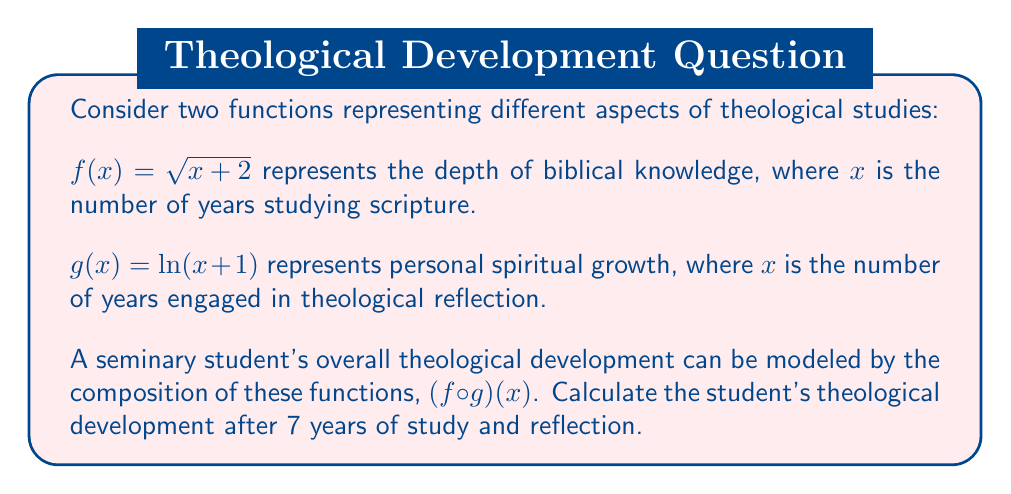Give your solution to this math problem. To solve this problem, we need to follow these steps:

1) First, we need to understand what $(f \circ g)(x)$ means. This is a composition of functions where we apply $g$ first, then apply $f$ to the result.

2) The formula for $(f \circ g)(x)$ is:

   $$(f \circ g)(x) = f(g(x)) = \sqrt{g(x) + 2}$$

3) Now, we need to calculate $g(7)$ since we're interested in the development after 7 years:

   $$g(7) = \ln(7 + 1) = \ln(8)$$

4) Next, we apply $f$ to this result:

   $$(f \circ g)(7) = f(g(7)) = f(\ln(8)) = \sqrt{\ln(8) + 2}$$

5) To calculate this:
   - $\ln(8) \approx 2.0794$
   - $2.0794 + 2 = 4.0794$
   - $\sqrt{4.0794} \approx 2.0197$

Therefore, after 7 years of study and reflection, the student's theological development is approximately 2.0197 units on this composite scale.

This result demonstrates how biblical knowledge and personal spiritual growth interact to produce overall theological development, reflecting the interdisciplinary nature of theological studies.
Answer: $(f \circ g)(7) = \sqrt{\ln(8) + 2} \approx 2.0197$ 